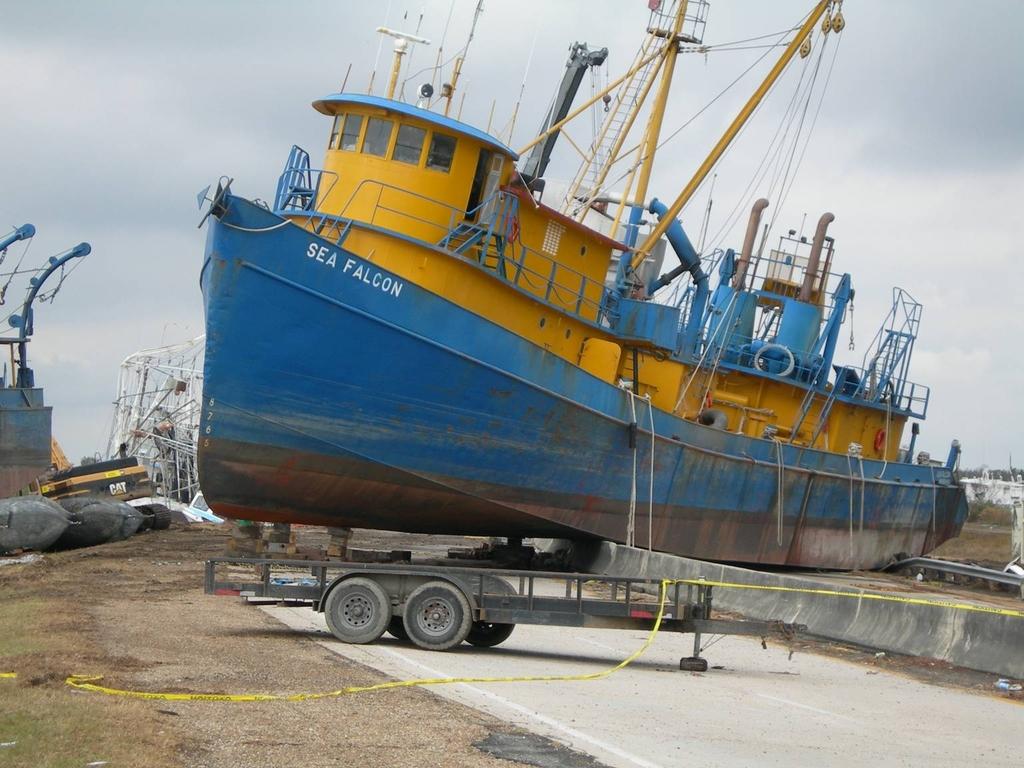What are the words on the ship?
Your response must be concise. Sea falcon. What does it say on the yellow tape?
Offer a terse response. Caution. 